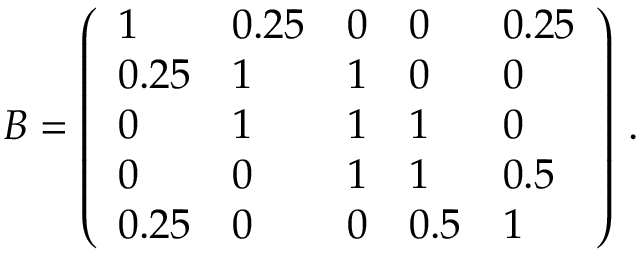<formula> <loc_0><loc_0><loc_500><loc_500>B = \left ( \begin{array} { l l l l l } { 1 } & { 0 . 2 5 } & { 0 } & { 0 } & { 0 . 2 5 } \\ { 0 . 2 5 } & { 1 } & { 1 } & { 0 } & { 0 } \\ { 0 } & { 1 } & { 1 } & { 1 } & { 0 } \\ { 0 } & { 0 } & { 1 } & { 1 } & { 0 . 5 } \\ { 0 . 2 5 } & { 0 } & { 0 } & { 0 . 5 } & { 1 } \end{array} \right ) \, .</formula> 